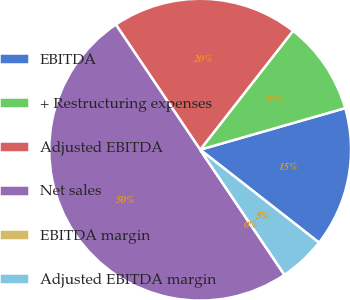Convert chart. <chart><loc_0><loc_0><loc_500><loc_500><pie_chart><fcel>EBITDA<fcel>+ Restructuring expenses<fcel>Adjusted EBITDA<fcel>Net sales<fcel>EBITDA margin<fcel>Adjusted EBITDA margin<nl><fcel>15.0%<fcel>10.0%<fcel>20.0%<fcel>50.0%<fcel>0.0%<fcel>5.0%<nl></chart> 